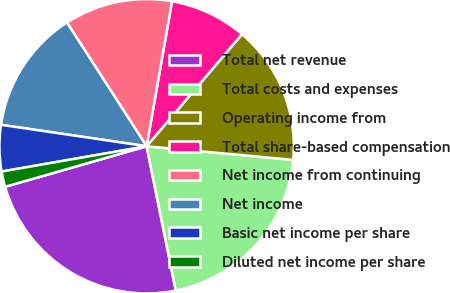Convert chart to OTSL. <chart><loc_0><loc_0><loc_500><loc_500><pie_chart><fcel>Total net revenue<fcel>Total costs and expenses<fcel>Operating income from<fcel>Total share-based compensation<fcel>Net income from continuing<fcel>Net income<fcel>Basic net income per share<fcel>Diluted net income per share<nl><fcel>23.73%<fcel>20.34%<fcel>15.25%<fcel>8.47%<fcel>11.86%<fcel>13.56%<fcel>5.08%<fcel>1.69%<nl></chart> 